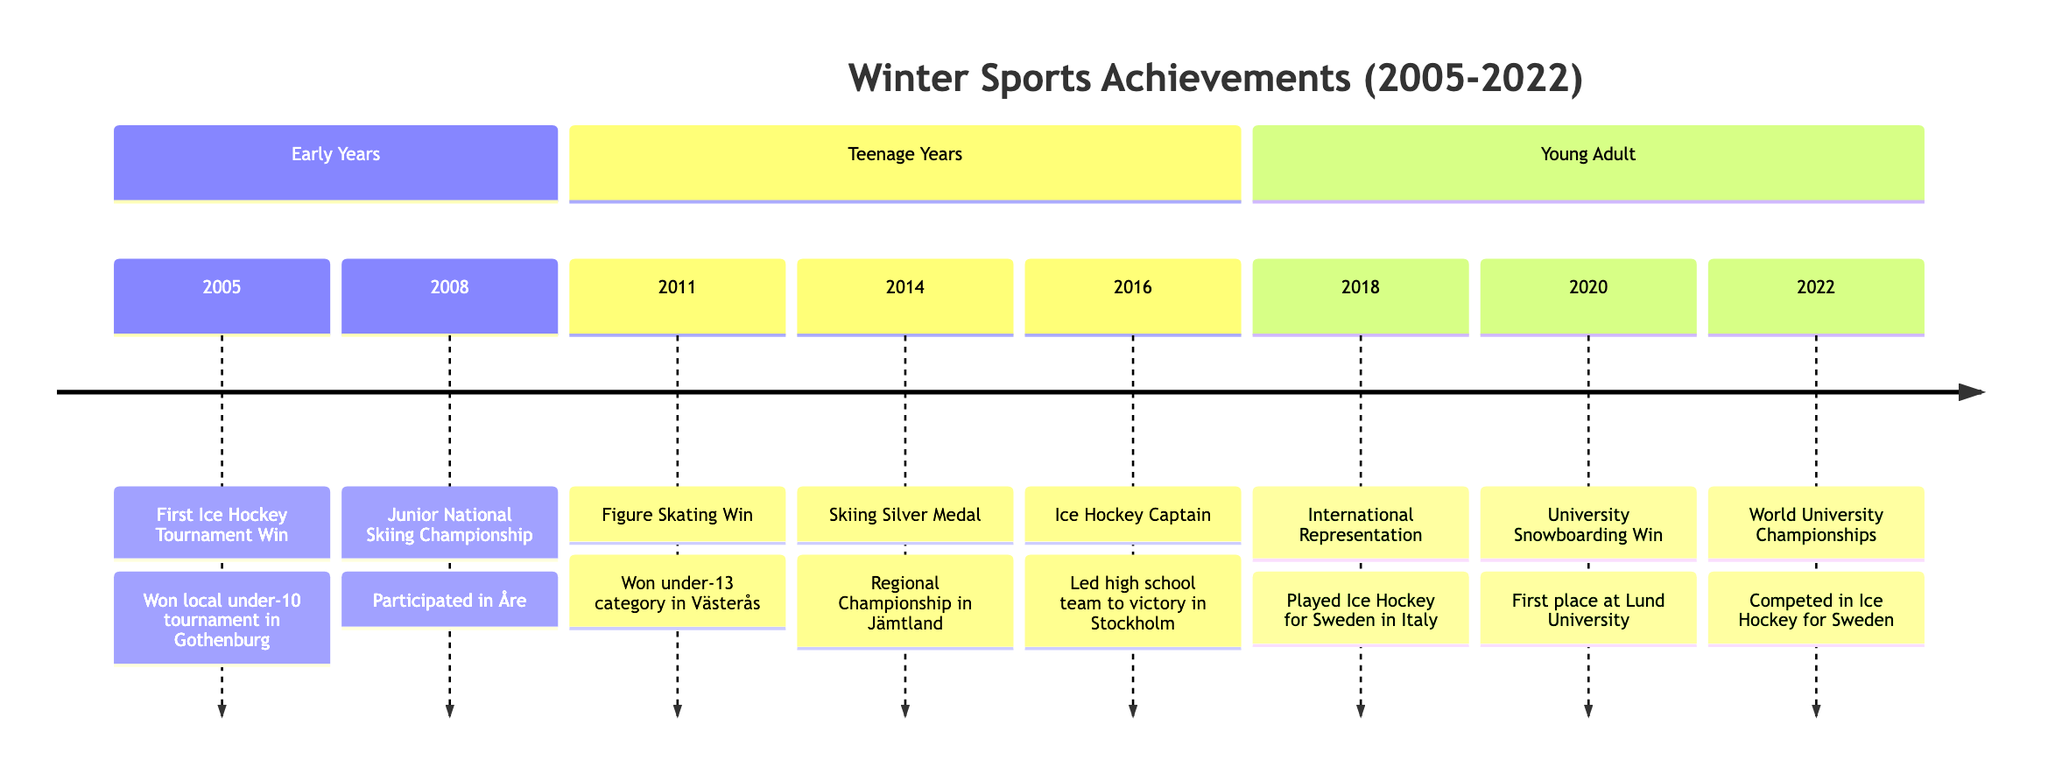What year did you win the first ice hockey tournament? According to the timeline, the first ice hockey tournament win occurred in 2005.
Answer: 2005 Which event took place in 2014? The timeline indicates that in 2014, you secured a silver medal in the Regional Skiing Championship in Jämtland.
Answer: Skiing Silver Medal How many events are listed in the timeline? Counting the events in the timeline, there are a total of 8 events listed.
Answer: 8 In which event did you represent Sweden internationally? The timeline shows that you represented Sweden in Ice Hockey at the International Youth Winter Sports Festival held in Italy in 2018.
Answer: International Youth Winter Sports Festival What is the most recent event in the timeline? The last event listed in the timeline is the participation in the Ice Hockey World University Championships, which took place in 2022.
Answer: World University Championships Which sport had the earliest competition mentioned in the timeline? The timeline marks the earliest competition as the first ice hockey tournament win in 2005, indicating that ice hockey was the sport featured first.
Answer: Ice Hockey What was your achievement in the year 2020? In 2020, you won first place in the snowboarding competition at Lund University Winter Sports Championship.
Answer: University Snowboarding Championship In which year did you become captain of the high school ice hockey team? The timeline states that you became captain of the high school ice hockey team in 2016.
Answer: 2016 What category did you compete in during the 2011 Figure Skating Competition? According to the timeline, in 2011, you won the under-13 category in the Västerås Figure Skating Competition.
Answer: under-13 category 